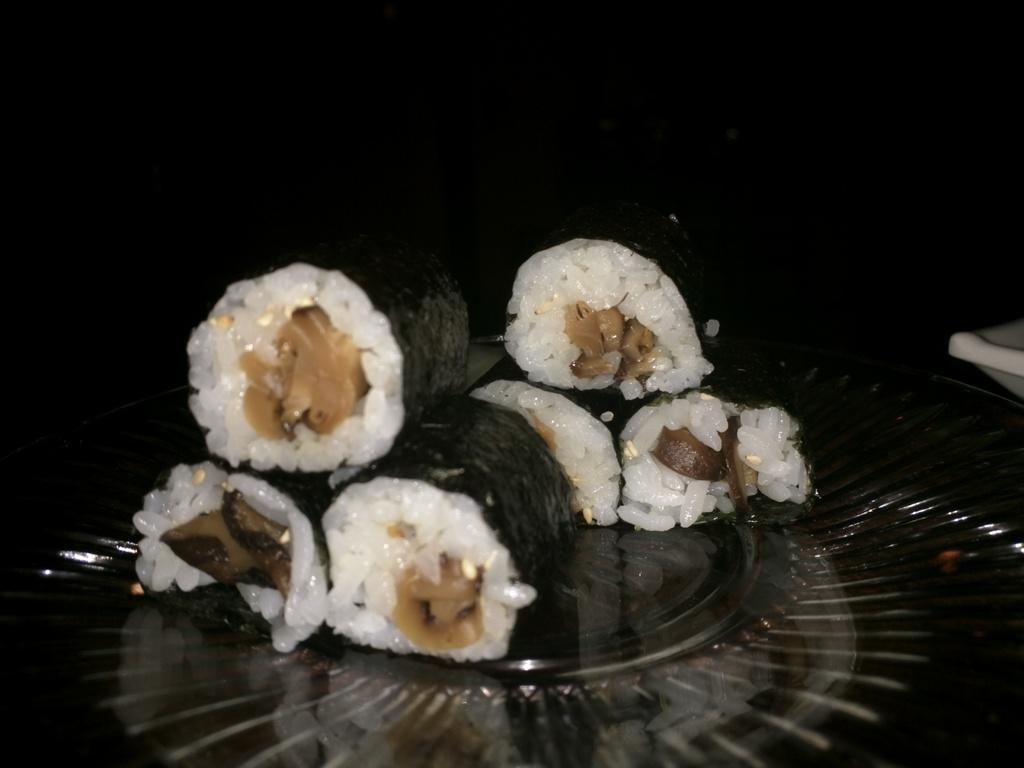What object is present in the image that typically holds food? There is a plate in the image. What is on the plate in the image? There is food on the plate. What country is the doctor using as bait in the image? There is no country, doctor, or bait present in the image. 